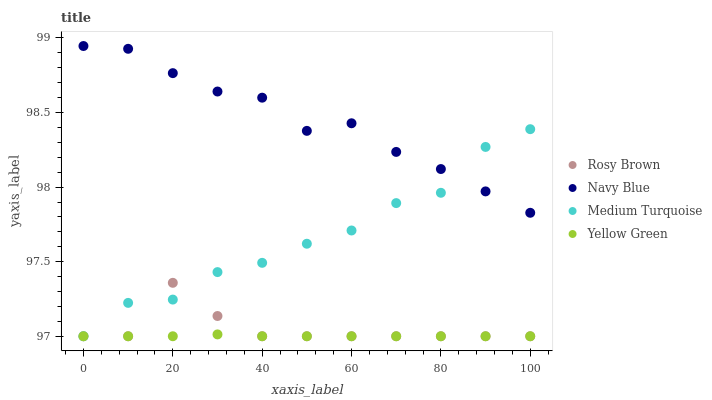Does Yellow Green have the minimum area under the curve?
Answer yes or no. Yes. Does Navy Blue have the maximum area under the curve?
Answer yes or no. Yes. Does Rosy Brown have the minimum area under the curve?
Answer yes or no. No. Does Rosy Brown have the maximum area under the curve?
Answer yes or no. No. Is Yellow Green the smoothest?
Answer yes or no. Yes. Is Medium Turquoise the roughest?
Answer yes or no. Yes. Is Rosy Brown the smoothest?
Answer yes or no. No. Is Rosy Brown the roughest?
Answer yes or no. No. Does Rosy Brown have the lowest value?
Answer yes or no. Yes. Does Navy Blue have the highest value?
Answer yes or no. Yes. Does Rosy Brown have the highest value?
Answer yes or no. No. Is Yellow Green less than Navy Blue?
Answer yes or no. Yes. Is Navy Blue greater than Yellow Green?
Answer yes or no. Yes. Does Yellow Green intersect Rosy Brown?
Answer yes or no. Yes. Is Yellow Green less than Rosy Brown?
Answer yes or no. No. Is Yellow Green greater than Rosy Brown?
Answer yes or no. No. Does Yellow Green intersect Navy Blue?
Answer yes or no. No. 